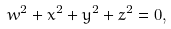<formula> <loc_0><loc_0><loc_500><loc_500>w ^ { 2 } + x ^ { 2 } + y ^ { 2 } + z ^ { 2 } = 0 ,</formula> 